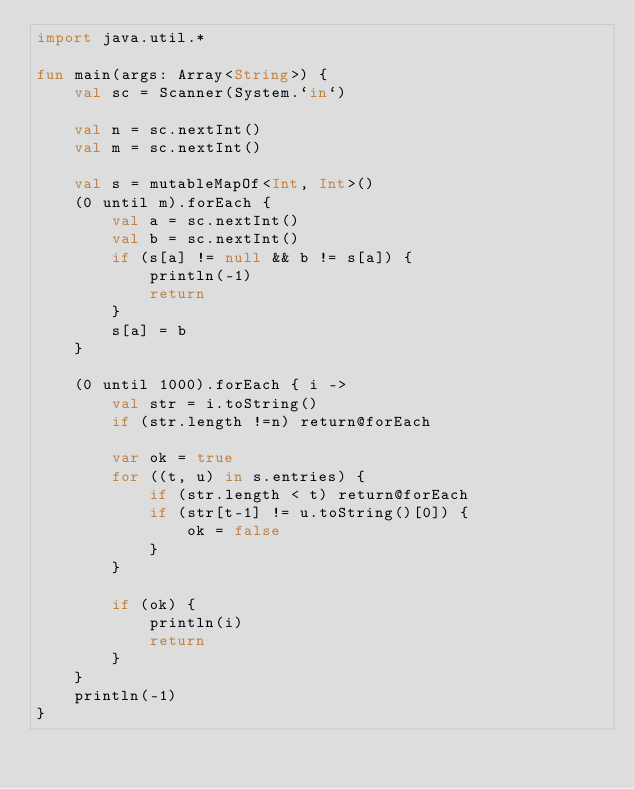<code> <loc_0><loc_0><loc_500><loc_500><_Kotlin_>import java.util.*

fun main(args: Array<String>) {
    val sc = Scanner(System.`in`)

    val n = sc.nextInt()
    val m = sc.nextInt()

    val s = mutableMapOf<Int, Int>()
    (0 until m).forEach {
        val a = sc.nextInt()
        val b = sc.nextInt()
        if (s[a] != null && b != s[a]) {
            println(-1)
            return
        }
        s[a] = b
    }

    (0 until 1000).forEach { i ->
        val str = i.toString()
        if (str.length !=n) return@forEach

        var ok = true
        for ((t, u) in s.entries) {
            if (str.length < t) return@forEach
            if (str[t-1] != u.toString()[0]) {
                ok = false
            }
        }

        if (ok) {
            println(i)
            return
        }
    }
    println(-1)
}</code> 